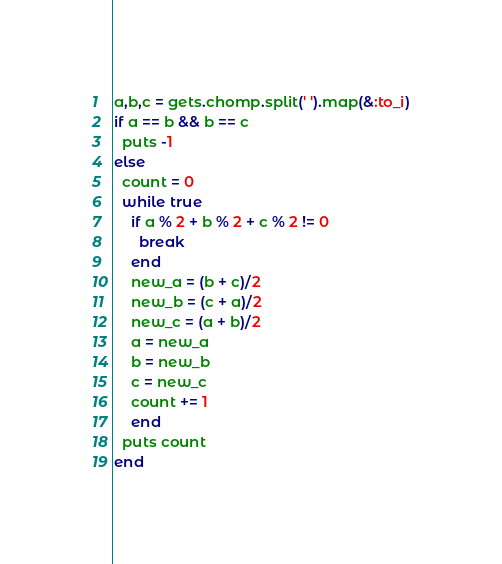<code> <loc_0><loc_0><loc_500><loc_500><_Ruby_>a,b,c = gets.chomp.split(' ').map(&:to_i)
if a == b && b == c
  puts -1
else
  count = 0
  while true
    if a % 2 + b % 2 + c % 2 != 0
      break
    end 
    new_a = (b + c)/2
    new_b = (c + a)/2
    new_c = (a + b)/2
    a = new_a
    b = new_b
    c = new_c
    count += 1
    end
  puts count
end</code> 